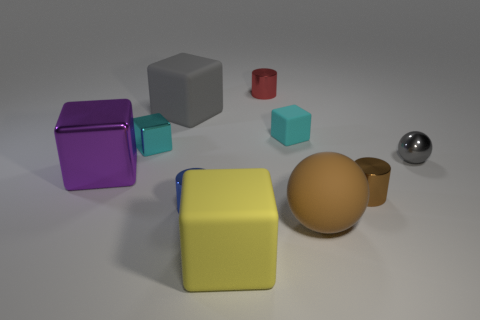Subtract all small cubes. How many cubes are left? 3 Subtract all brown spheres. How many spheres are left? 1 Subtract all balls. How many objects are left? 8 Subtract all brown cubes. How many brown spheres are left? 1 Subtract 0 blue cubes. How many objects are left? 10 Subtract 2 cylinders. How many cylinders are left? 1 Subtract all yellow balls. Subtract all purple cylinders. How many balls are left? 2 Subtract all small cyan shiny cubes. Subtract all small blue cylinders. How many objects are left? 8 Add 7 big yellow cubes. How many big yellow cubes are left? 8 Add 1 tiny matte things. How many tiny matte things exist? 2 